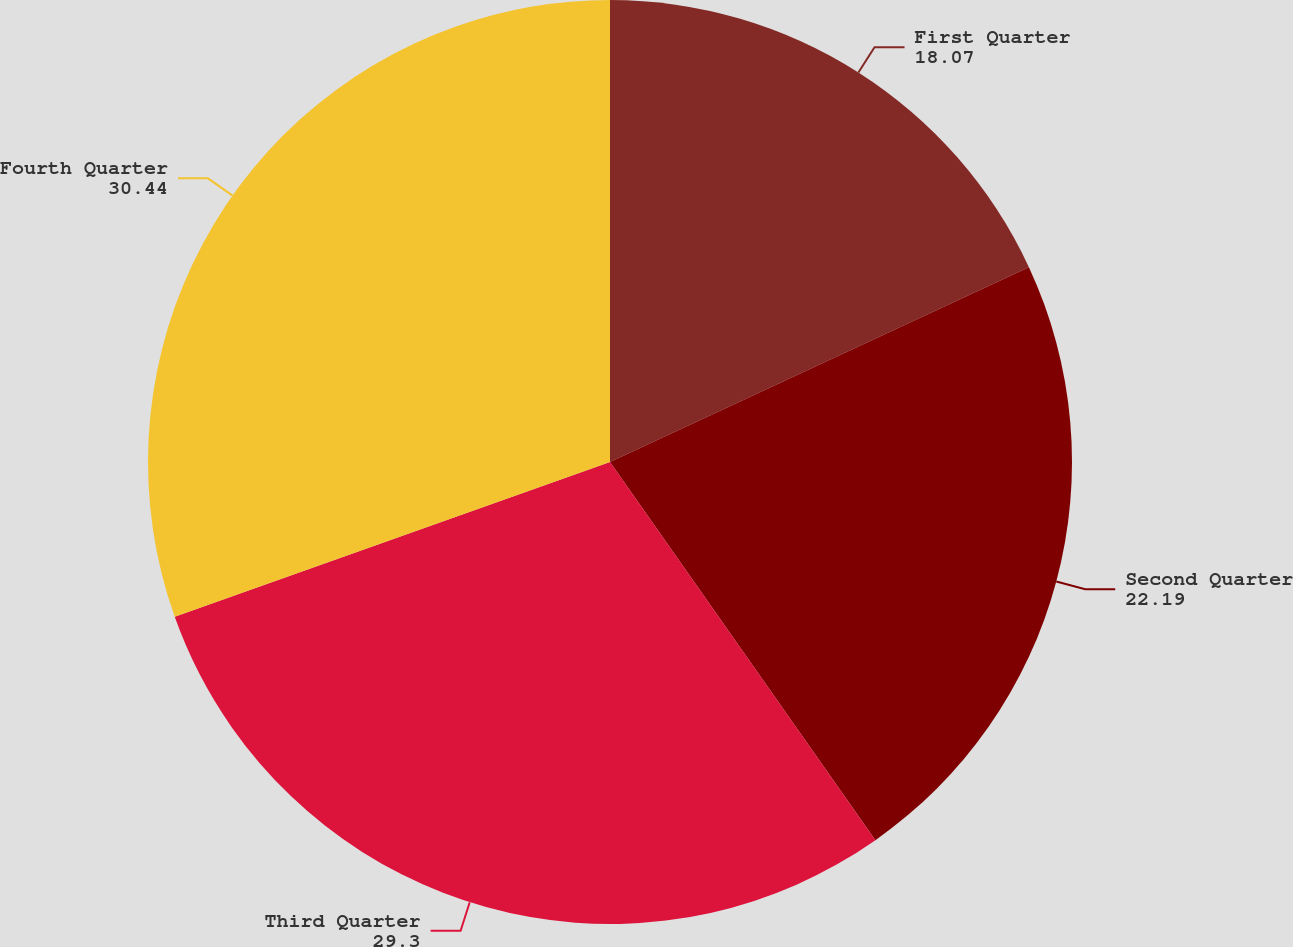Convert chart. <chart><loc_0><loc_0><loc_500><loc_500><pie_chart><fcel>First Quarter<fcel>Second Quarter<fcel>Third Quarter<fcel>Fourth Quarter<nl><fcel>18.07%<fcel>22.19%<fcel>29.3%<fcel>30.44%<nl></chart> 